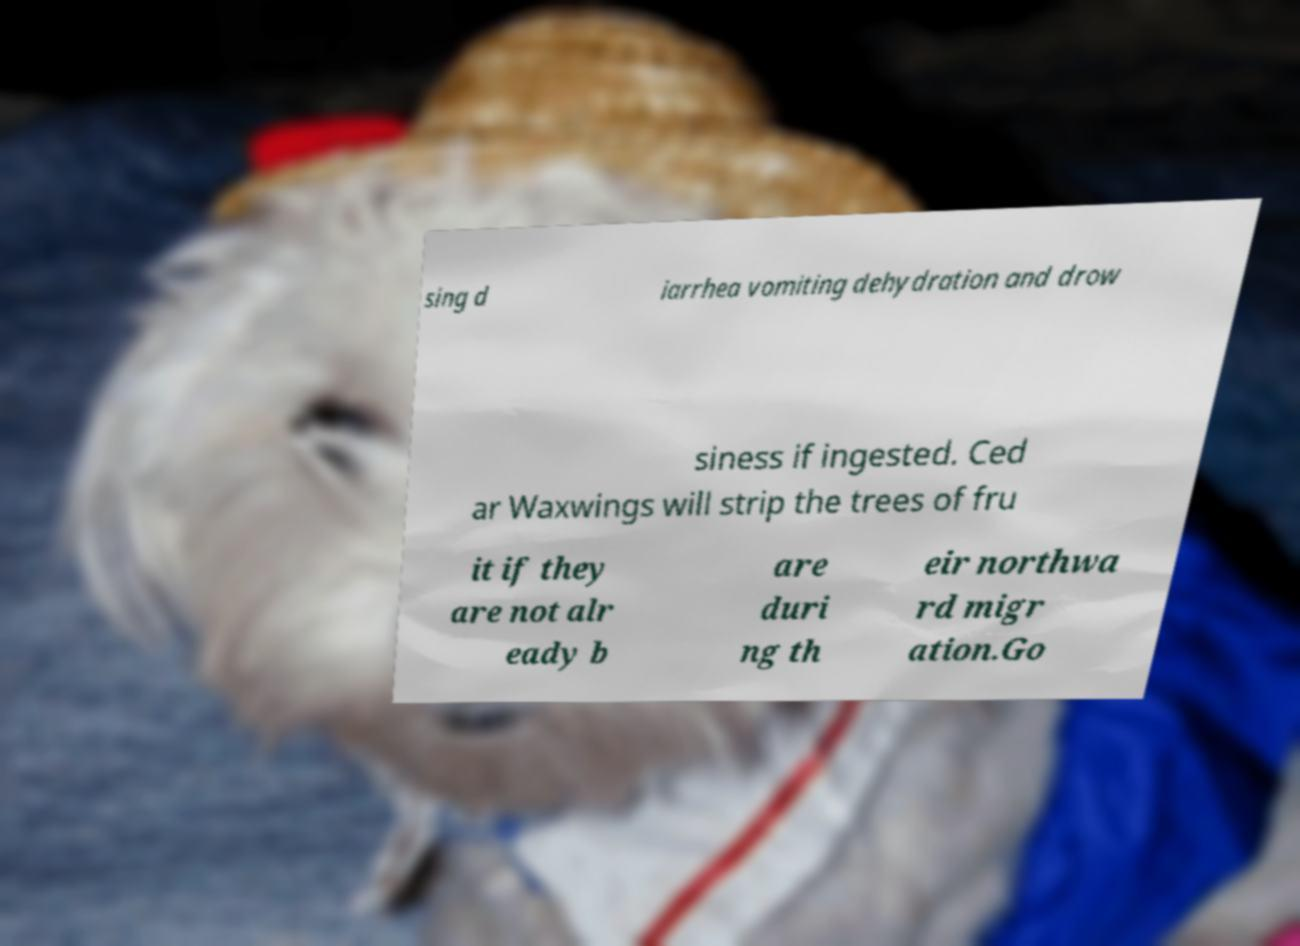Could you extract and type out the text from this image? sing d iarrhea vomiting dehydration and drow siness if ingested. Ced ar Waxwings will strip the trees of fru it if they are not alr eady b are duri ng th eir northwa rd migr ation.Go 